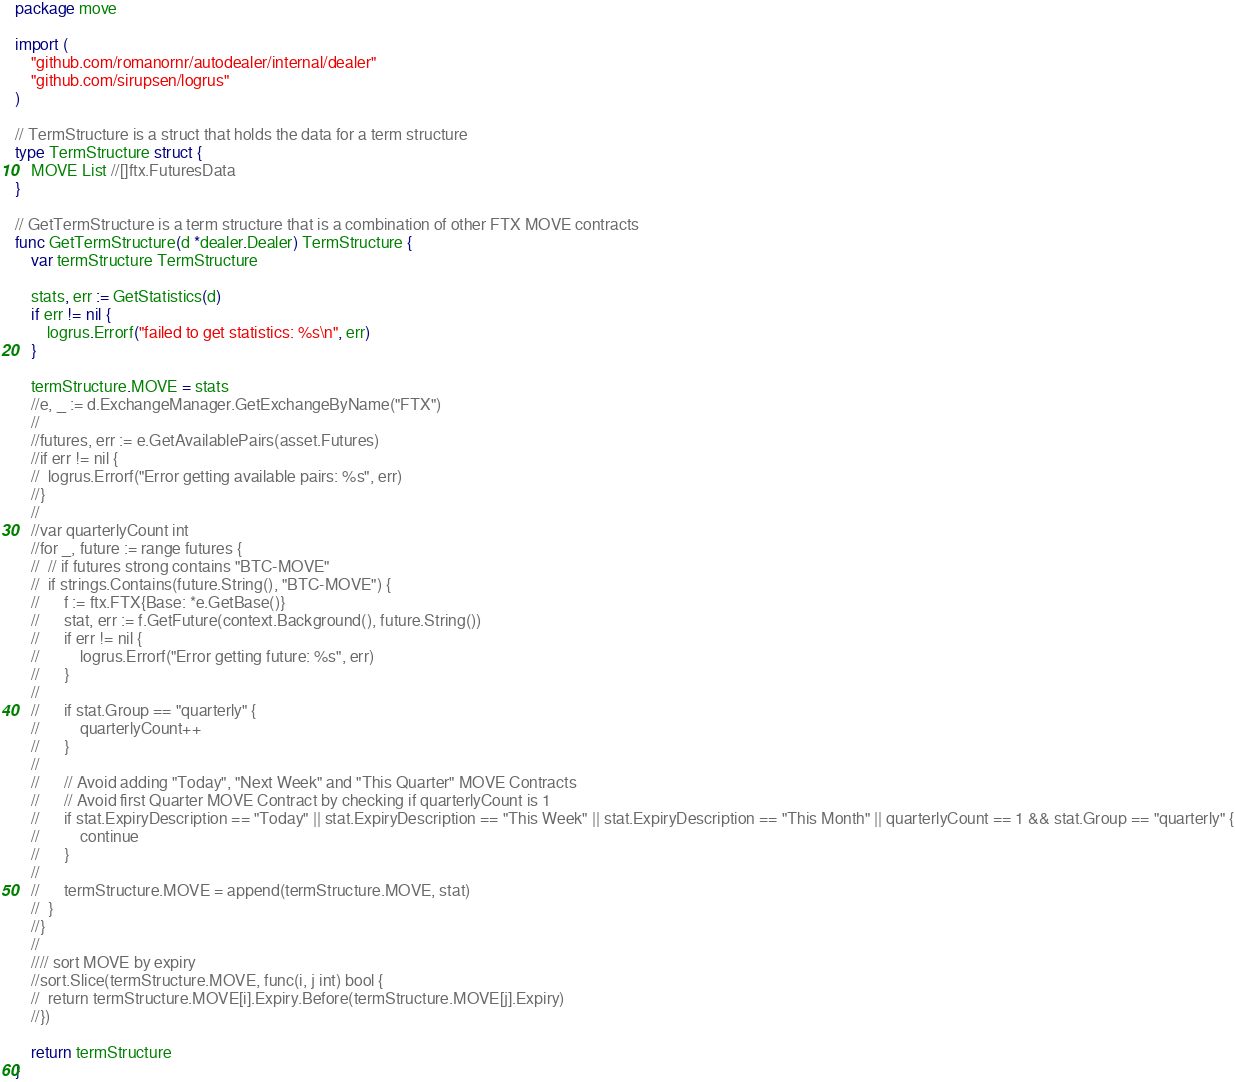Convert code to text. <code><loc_0><loc_0><loc_500><loc_500><_Go_>package move

import (
	"github.com/romanornr/autodealer/internal/dealer"
	"github.com/sirupsen/logrus"
)

// TermStructure is a struct that holds the data for a term structure
type TermStructure struct {
	MOVE List //[]ftx.FuturesData
}

// GetTermStructure is a term structure that is a combination of other FTX MOVE contracts
func GetTermStructure(d *dealer.Dealer) TermStructure {
	var termStructure TermStructure

	stats, err := GetStatistics(d)
	if err != nil {
		logrus.Errorf("failed to get statistics: %s\n", err)
	}

	termStructure.MOVE = stats
	//e, _ := d.ExchangeManager.GetExchangeByName("FTX")
	//
	//futures, err := e.GetAvailablePairs(asset.Futures)
	//if err != nil {
	//	logrus.Errorf("Error getting available pairs: %s", err)
	//}
	//
	//var quarterlyCount int
	//for _, future := range futures {
	//	// if futures strong contains "BTC-MOVE"
	//	if strings.Contains(future.String(), "BTC-MOVE") {
	//		f := ftx.FTX{Base: *e.GetBase()}
	//		stat, err := f.GetFuture(context.Background(), future.String())
	//		if err != nil {
	//			logrus.Errorf("Error getting future: %s", err)
	//		}
	//
	//		if stat.Group == "quarterly" {
	//			quarterlyCount++
	//		}
	//
	//		// Avoid adding "Today", "Next Week" and "This Quarter" MOVE Contracts
	//		// Avoid first Quarter MOVE Contract by checking if quarterlyCount is 1
	//		if stat.ExpiryDescription == "Today" || stat.ExpiryDescription == "This Week" || stat.ExpiryDescription == "This Month" || quarterlyCount == 1 && stat.Group == "quarterly" {
	//			continue
	//		}
	//
	//		termStructure.MOVE = append(termStructure.MOVE, stat)
	//	}
	//}
	//
	//// sort MOVE by expiry
	//sort.Slice(termStructure.MOVE, func(i, j int) bool {
	//	return termStructure.MOVE[i].Expiry.Before(termStructure.MOVE[j].Expiry)
	//})

	return termStructure
}
</code> 